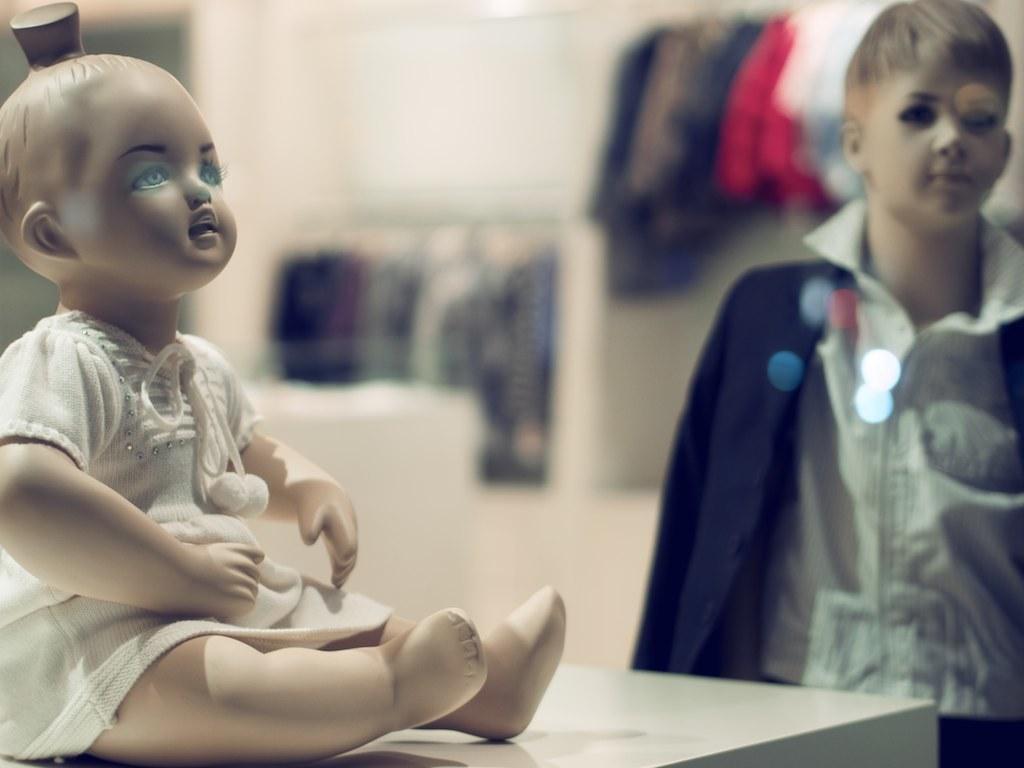Please provide a concise description of this image. In this image we can see there is a doll and a mannequin. There are clothes. 